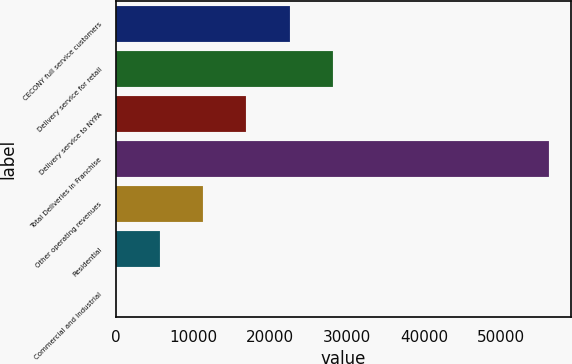Convert chart. <chart><loc_0><loc_0><loc_500><loc_500><bar_chart><fcel>CECONY full service customers<fcel>Delivery service for retail<fcel>Delivery service to NYPA<fcel>Total Deliveries in Franchise<fcel>Other operating revenues<fcel>Residential<fcel>Commercial and Industrial<nl><fcel>22534.5<fcel>28162.5<fcel>16906.4<fcel>56303<fcel>11278.3<fcel>5650.19<fcel>22.1<nl></chart> 